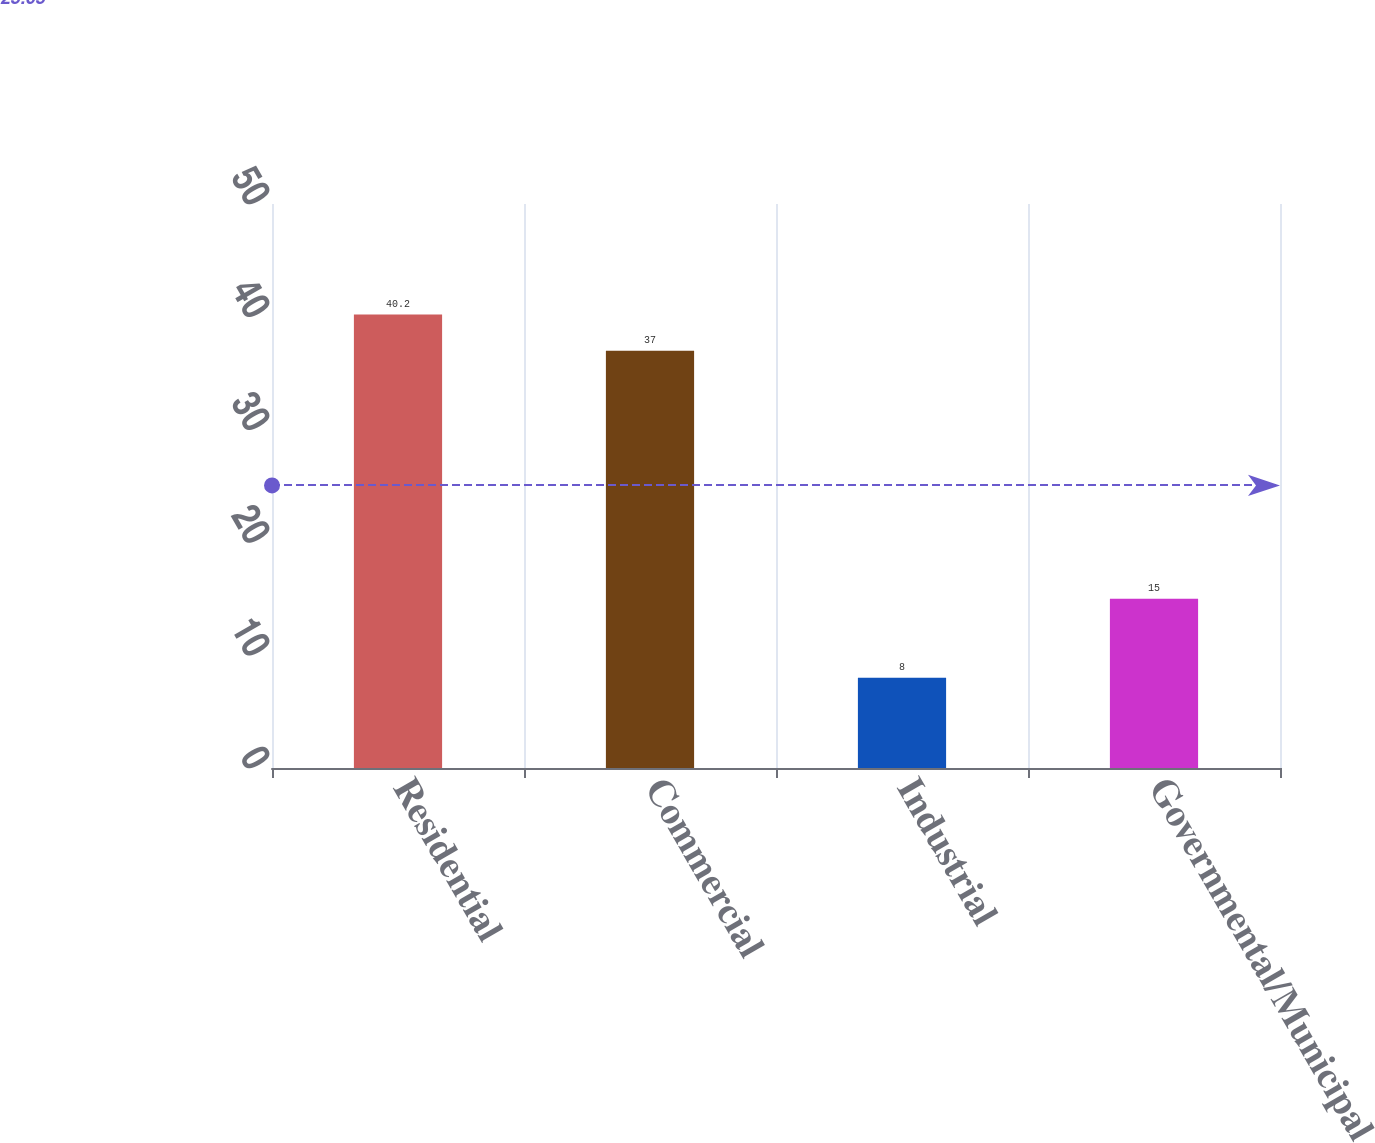<chart> <loc_0><loc_0><loc_500><loc_500><bar_chart><fcel>Residential<fcel>Commercial<fcel>Industrial<fcel>Governmental/Municipal<nl><fcel>40.2<fcel>37<fcel>8<fcel>15<nl></chart> 